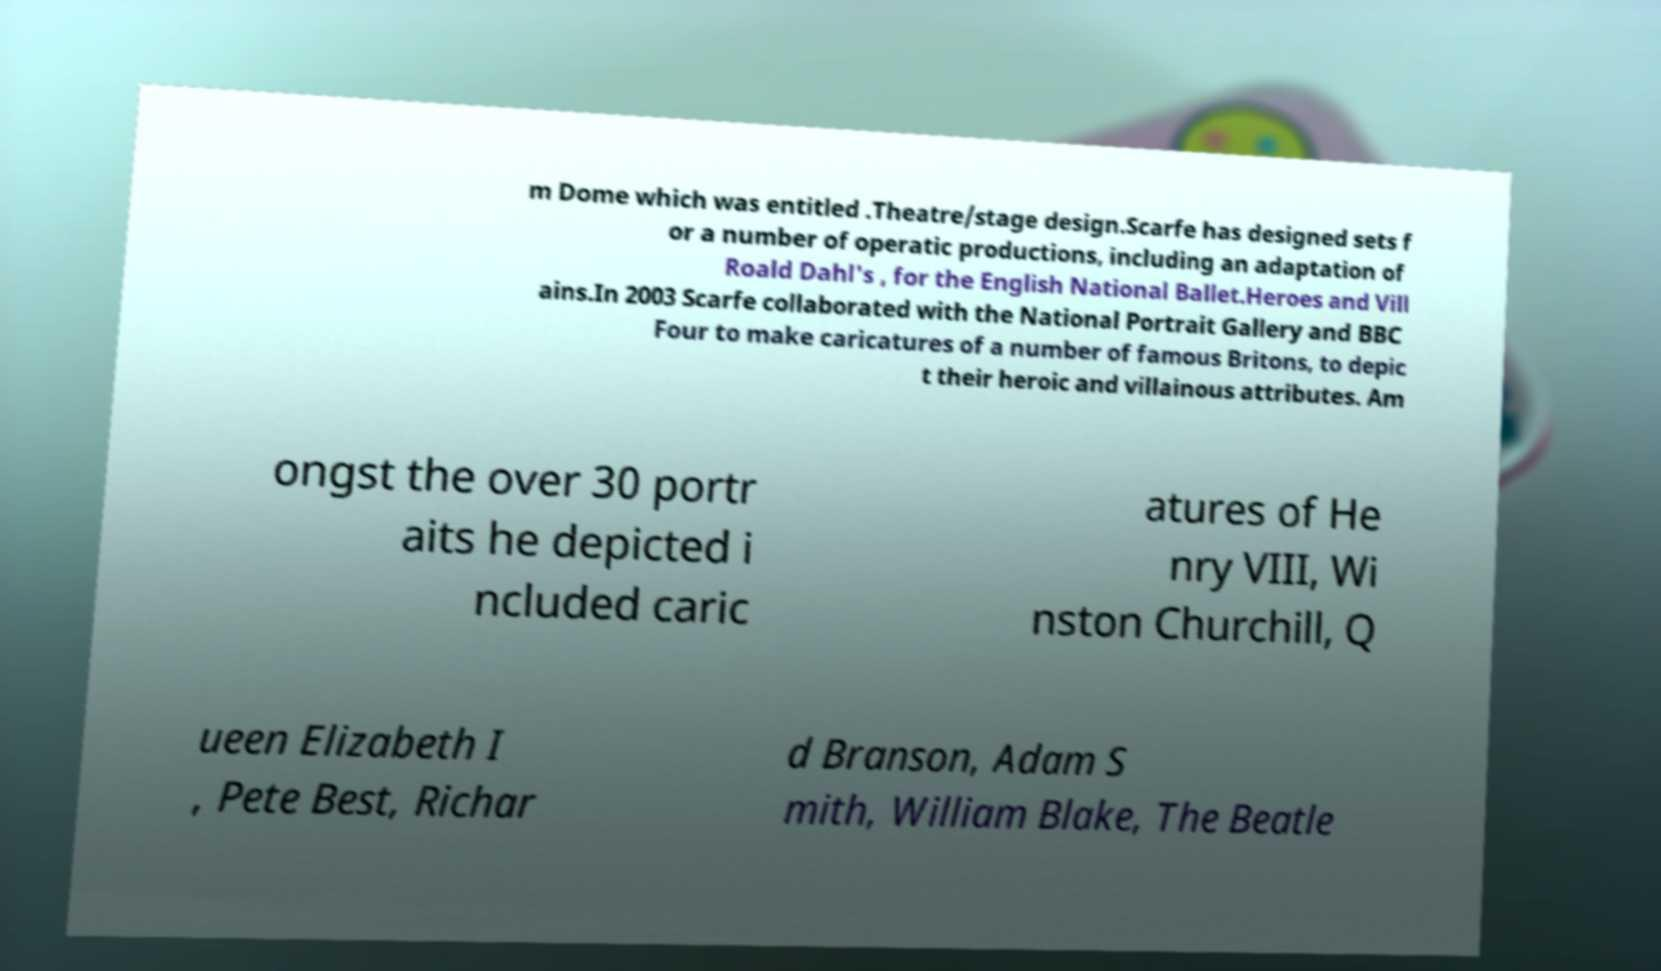Could you extract and type out the text from this image? m Dome which was entitled .Theatre/stage design.Scarfe has designed sets f or a number of operatic productions, including an adaptation of Roald Dahl's , for the English National Ballet.Heroes and Vill ains.In 2003 Scarfe collaborated with the National Portrait Gallery and BBC Four to make caricatures of a number of famous Britons, to depic t their heroic and villainous attributes. Am ongst the over 30 portr aits he depicted i ncluded caric atures of He nry VIII, Wi nston Churchill, Q ueen Elizabeth I , Pete Best, Richar d Branson, Adam S mith, William Blake, The Beatle 